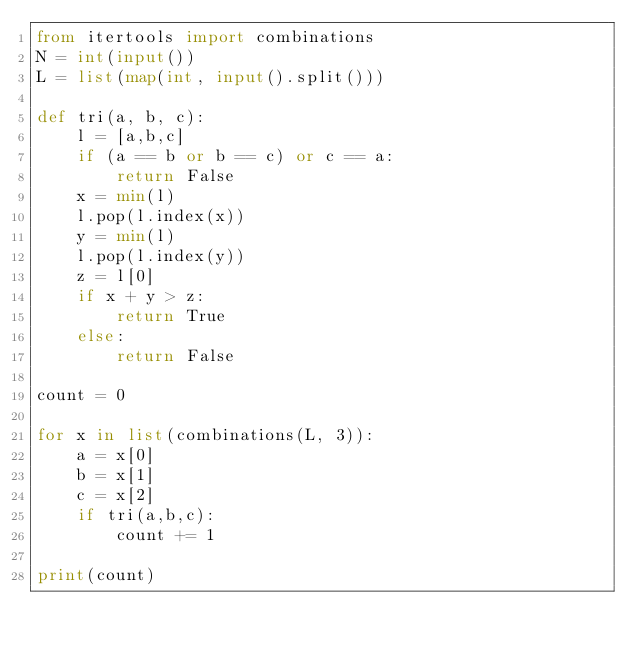Convert code to text. <code><loc_0><loc_0><loc_500><loc_500><_Python_>from itertools import combinations
N = int(input())
L = list(map(int, input().split()))

def tri(a, b, c):
    l = [a,b,c]
    if (a == b or b == c) or c == a:
        return False
    x = min(l)
    l.pop(l.index(x))
    y = min(l)
    l.pop(l.index(y))
    z = l[0]
    if x + y > z:
        return True
    else:
        return False

count = 0

for x in list(combinations(L, 3)):
    a = x[0]
    b = x[1]
    c = x[2]
    if tri(a,b,c):
        count += 1

print(count)</code> 